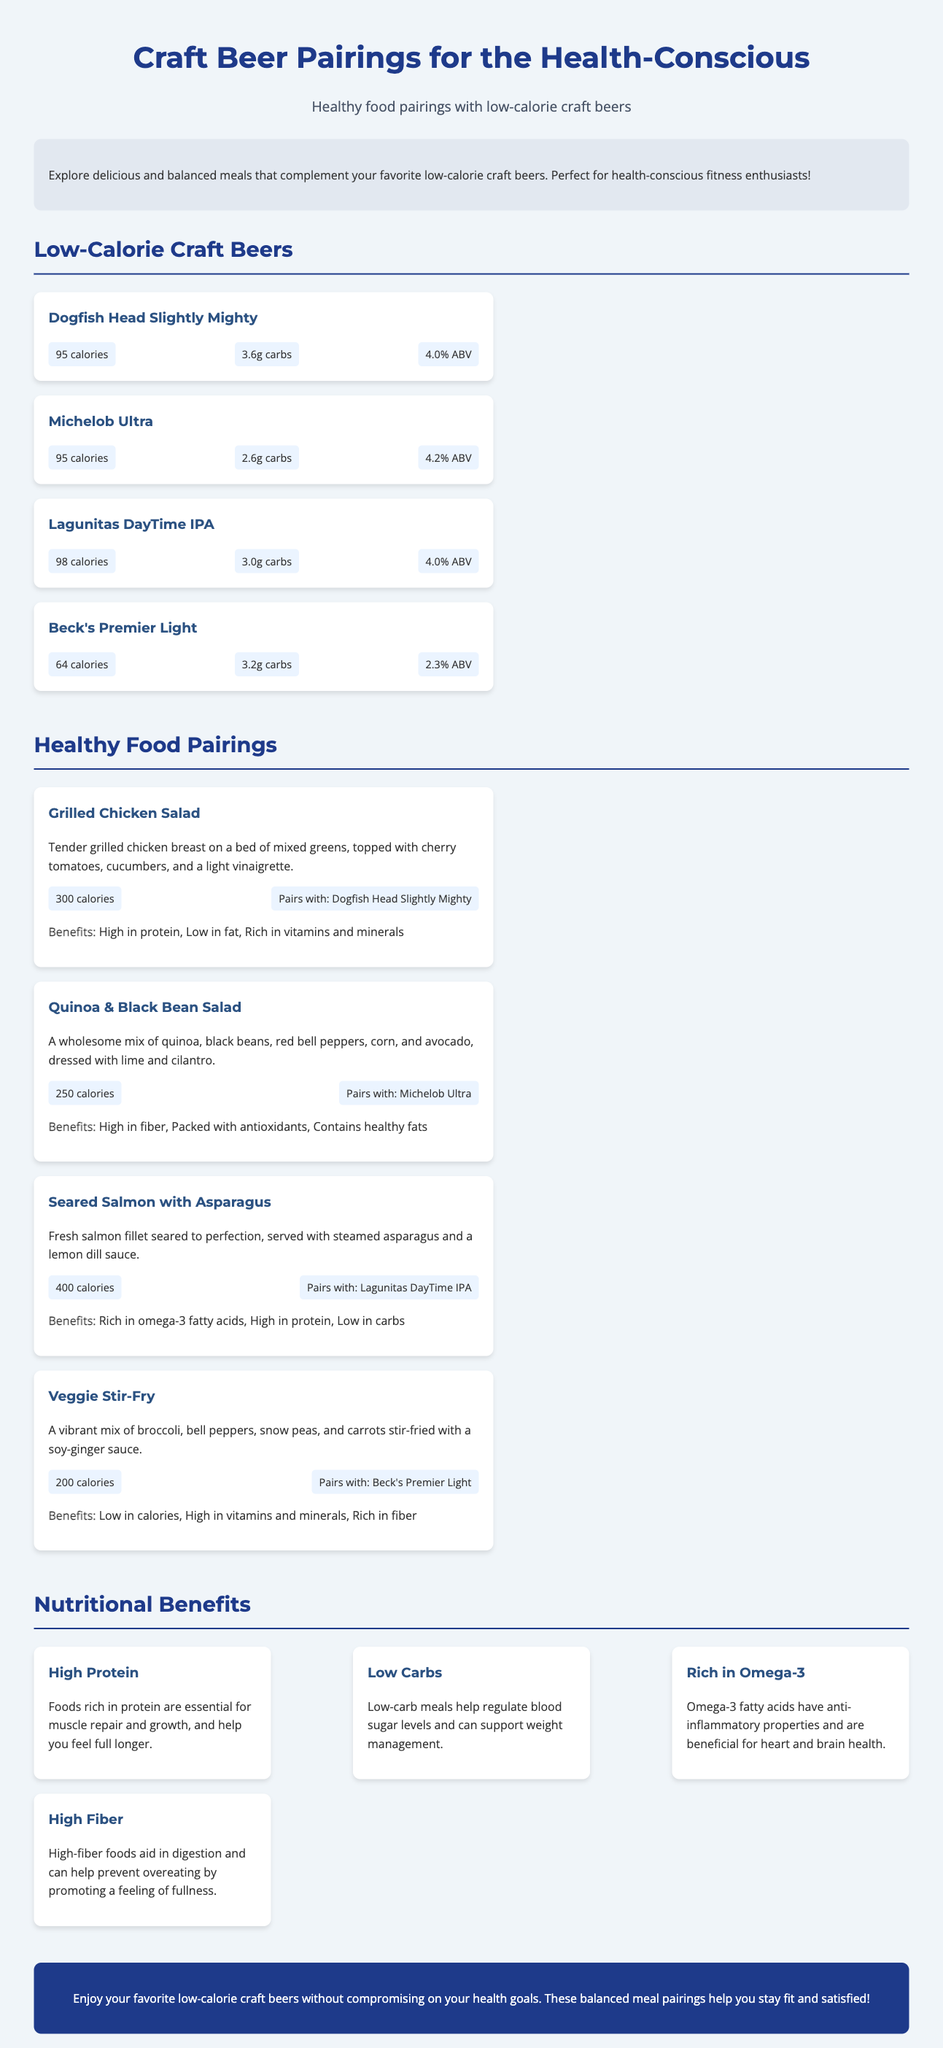What is the calorie count of Dogfish Head Slightly Mighty? Dogfish Head Slightly Mighty has a calorie count of 95, as mentioned in the beer details section.
Answer: 95 calories What is the main ingredient in the Grilled Chicken Salad? The Grilled Chicken Salad primarily features tender grilled chicken breast on a bed of mixed greens.
Answer: Grilled chicken breast Which craft beer pairs with Quinoa & Black Bean Salad? The pairing information states that Quinoa & Black Bean Salad pairs with Michelob Ultra.
Answer: Michelob Ultra What is one of the nutritional benefits mentioned in the document? The document lists multiple benefits; one example is "High Protein," which explains essential muscle repair.
Answer: High Protein How many calories are in the Veggie Stir-Fry? The Veggie Stir-Fry is described to contain 200 calories, which is provided in the food details.
Answer: 200 calories Which beer option has the lowest calorie count? Among the listed beer options, Beck's Premier Light has the lowest calorie count at 64.
Answer: 64 calories What type of fiber is emphasized in the document? The document specifically highlights "High Fiber" as one of the beneficial nutritional aspects.
Answer: High Fiber What meal is paired with Lagunitas DayTime IPA? The meal paired with Lagunitas DayTime IPA is Seared Salmon with Asparagus, as noted in the food pairings section.
Answer: Seared Salmon with Asparagus 